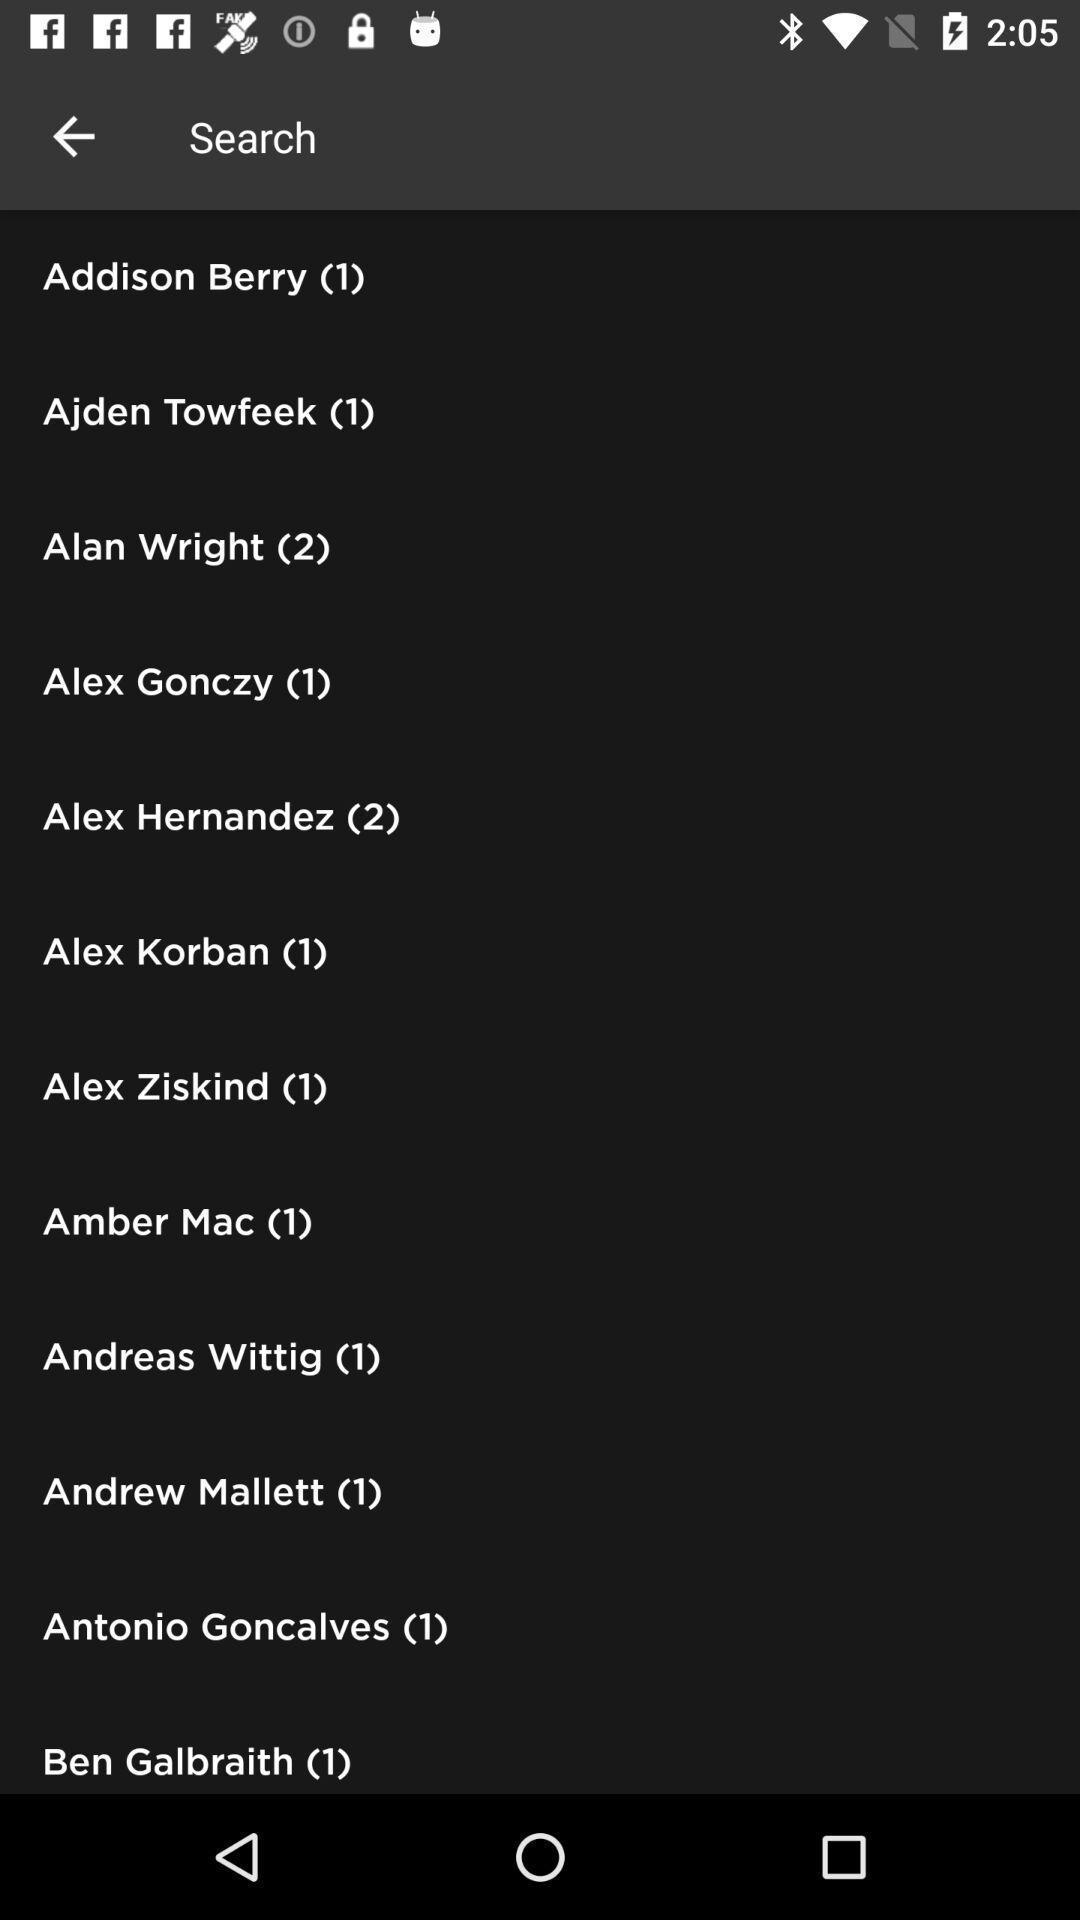Provide a detailed account of this screenshot. Screen displaying information of different technology skills. 